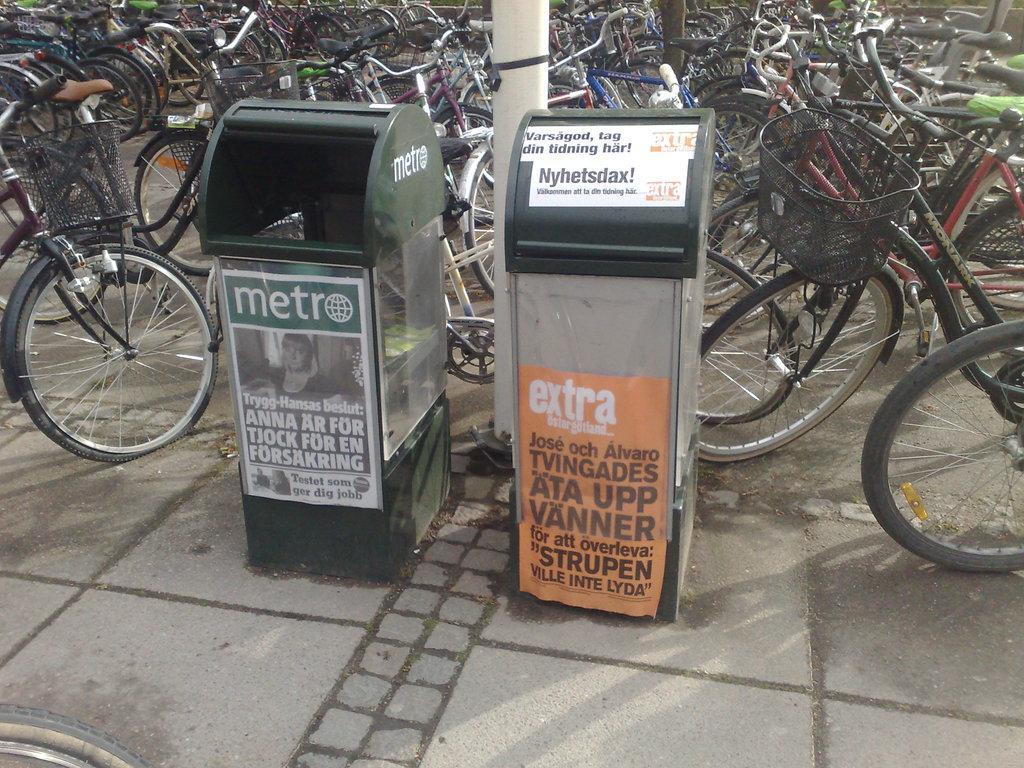Describe this image in one or two sentences. This image is taken outdoors. At the bottom of the image there is a road. In the middle of the image there are two dustbins with posters and text on them. In the background there are many bicycles parked on the road. 